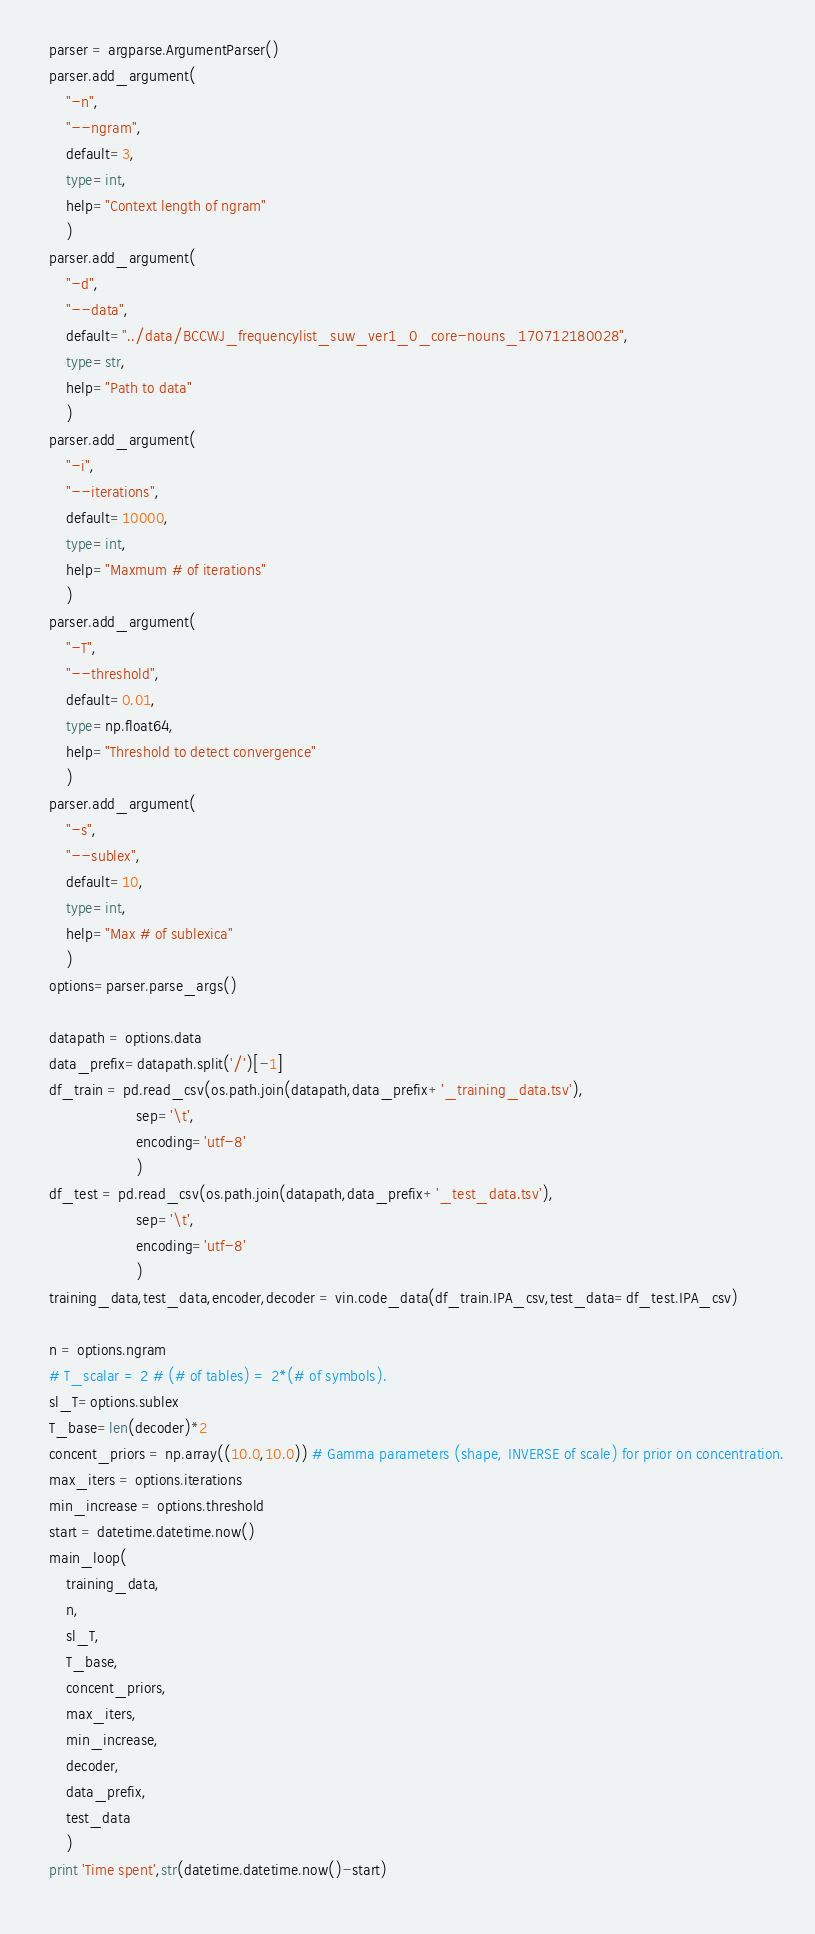<code> <loc_0><loc_0><loc_500><loc_500><_Python_>	parser = argparse.ArgumentParser()
	parser.add_argument(
		"-n",
		"--ngram",
		default=3,
		type=int,
		help="Context length of ngram"
		)
	parser.add_argument(
		"-d",
		"--data",
		default="../data/BCCWJ_frequencylist_suw_ver1_0_core-nouns_170712180028",
		type=str,
		help="Path to data"
		)
	parser.add_argument(
		"-i",
		"--iterations",
		default=10000,
		type=int,
		help="Maxmum # of iterations"
		)
	parser.add_argument(
		"-T",
		"--threshold",
		default=0.01,
		type=np.float64,
		help="Threshold to detect convergence"
		)
	parser.add_argument(
		"-s",
		"--sublex",
		default=10,
		type=int,
		help="Max # of sublexica"
		)
	options=parser.parse_args()
	
	datapath = options.data
	data_prefix=datapath.split('/')[-1]
	df_train = pd.read_csv(os.path.join(datapath,data_prefix+'_training_data.tsv'),
						sep='\t',
						encoding='utf-8'
						)
	df_test = pd.read_csv(os.path.join(datapath,data_prefix+'_test_data.tsv'),
						sep='\t',
						encoding='utf-8'
						)
	training_data,test_data,encoder,decoder = vin.code_data(df_train.IPA_csv,test_data=df_test.IPA_csv)
	
	n = options.ngram
	# T_scalar = 2 # (# of tables) = 2*(# of symbols).
	sl_T=options.sublex
	T_base=len(decoder)*2
	concent_priors = np.array((10.0,10.0)) # Gamma parameters (shape, INVERSE of scale) for prior on concentration.
	max_iters = options.iterations
	min_increase = options.threshold
	start = datetime.datetime.now()
	main_loop(
		training_data,
		n,
		sl_T,
		T_base,
		concent_priors,
		max_iters,
		min_increase,
		decoder,
		data_prefix,
		test_data
		)
	print 'Time spent',str(datetime.datetime.now()-start)
	
</code> 